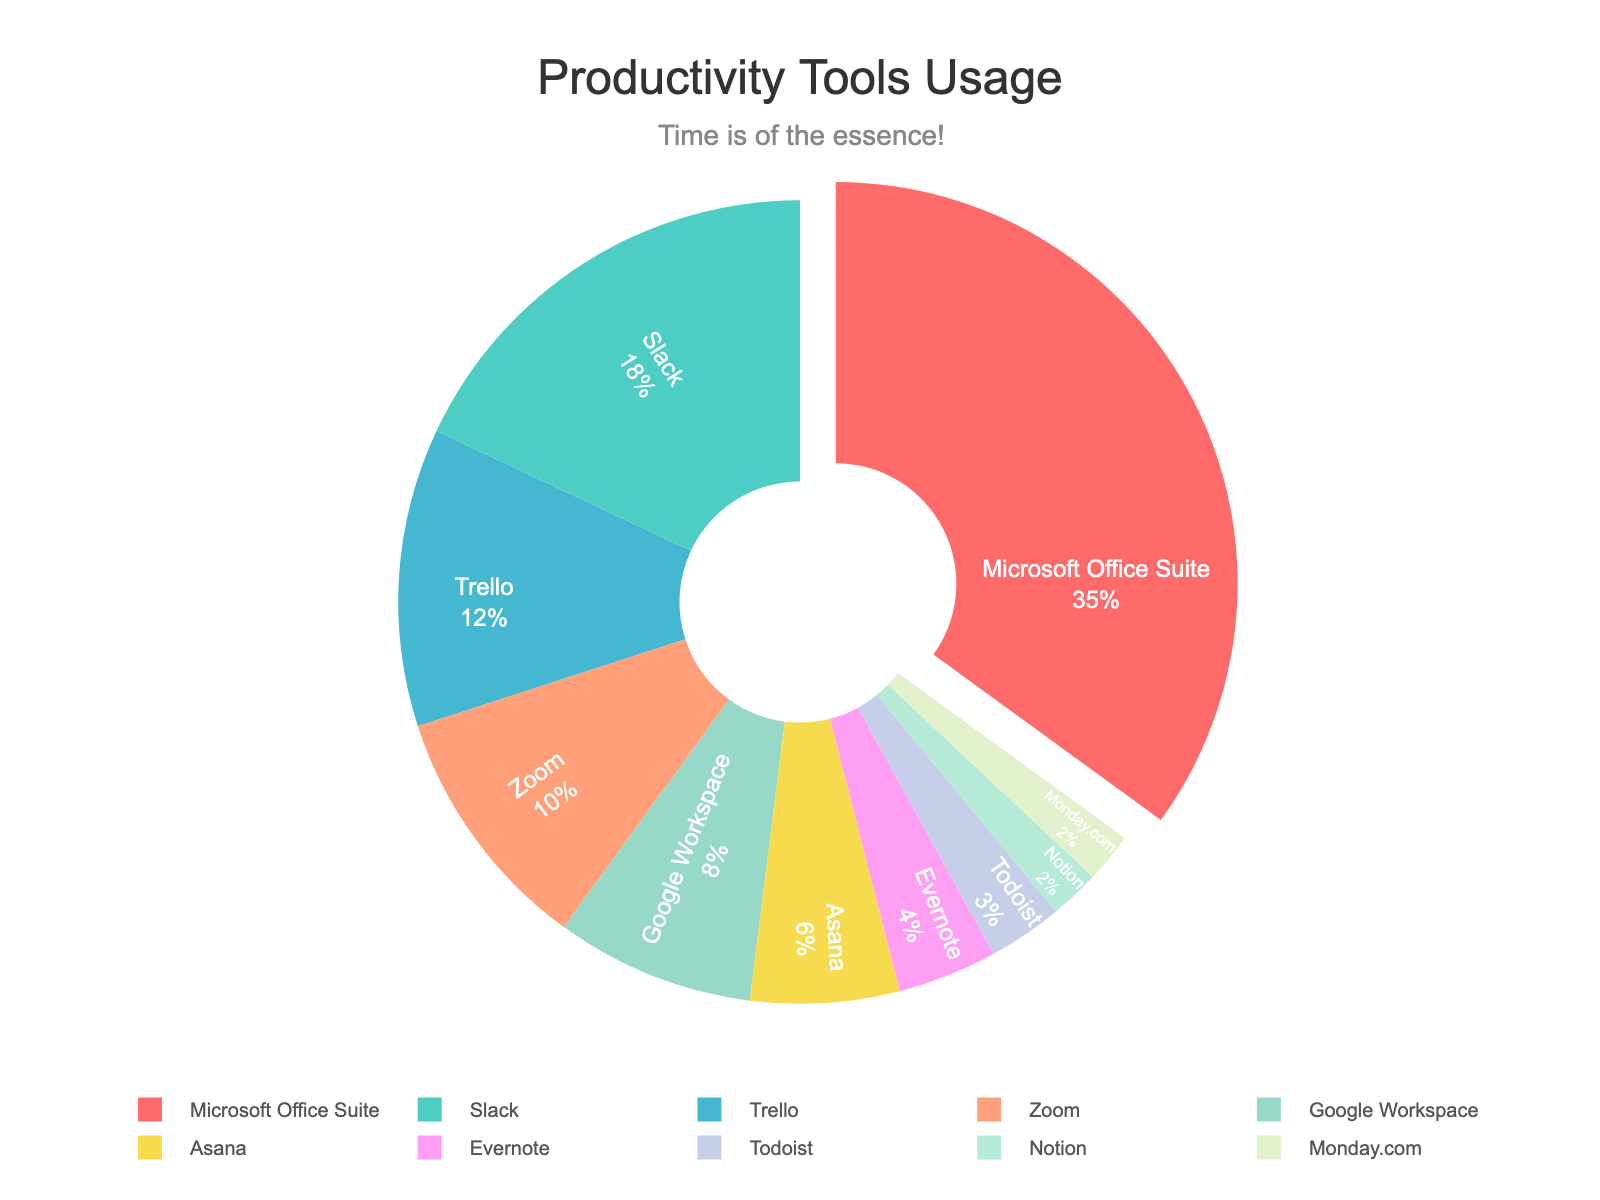What percentage of employees use Microsoft Office Suite compared to Slack? Microsoft Office Suite accounts for 35% while Slack accounts for 18%. By comparing 35% to 18%, it's clear that Microsoft Office Suite is used more by 17%.
Answer: 35% vs 18% What is the combined percentage of employees using Trello, Zoom, and Google Workspace? Trello is 12%, Zoom is 10%, and Google Workspace is 8%. The total percentage is the sum of these values: 12% + 10% + 8% = 30%.
Answer: 30% Which tool is used the least among Notion, Todoist, and Monday.com? According to the chart, Notion and Monday.com each have a 2% usage rate, which is less than Todoist's 3%. Therefore, Notion and Monday.com are used the least.
Answer: Notion and Monday.com What percentage of employees use tools other than Microsoft Office Suite, Slack, and Trello? First, sum the percentages of Microsoft Office Suite, Slack, and Trello: 35% + 18% + 12% = 65%. Then subtract this from 100% to find the remaining percentage: 100% - 65% = 35%.
Answer: 35% How does the usage of Microsoft Office Suite compare visually to Trello in the pie chart? The segment for Microsoft Office Suite is significantly larger and also pulled out from the pie chart, making it visually prominent compared to the segment for Trello.
Answer: Larger and more prominent Are there more employees using Zoom or Asana? Zoom has a usage percentage of 10%, while Asana has 6%. Therefore, more employees use Zoom than Asana.
Answer: Zoom Which category has the smallest representation in the pie chart, and what is its percentage? The smallest segment in the pie chart represents Notion and Monday.com, each with 2% usage.
Answer: Notion and Monday.com, 2% What is the total percentage represented by Evernote, Todoist, Notion, and Monday.com combined? Evernote is 4%, Todoist is 3%, Notion is 2%, and Monday.com is 2%. The total percentage is 4% + 3% + 2% + 2% = 11%.
Answer: 11% Which tools combined have a usage percentage equal to or greater than Microsoft Office Suite? Slack (18%) + Trello (12%) + Zoom (10%) = 40%, which is greater than Microsoft Office Suite's 35%. Another combination: Trello (12%) + Zoom (10%) + Google Workspace (8%) + Asana (6%) = 36%, which is also greater.
Answer: Slack, Trello, and Zoom What insight can you infer about the color coding of the pie chart? The colors of the pie chart segments are distinct and designed to show clear differentiation between tools. The most used tool (Microsoft Office Suite) segment uses a prominent color (red) and is pulled out for emphasis.
Answer: Color coding and emphasis 